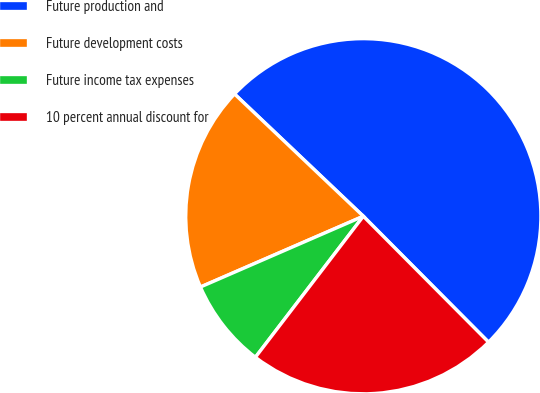Convert chart to OTSL. <chart><loc_0><loc_0><loc_500><loc_500><pie_chart><fcel>Future production and<fcel>Future development costs<fcel>Future income tax expenses<fcel>10 percent annual discount for<nl><fcel>50.46%<fcel>18.61%<fcel>8.08%<fcel>22.85%<nl></chart> 